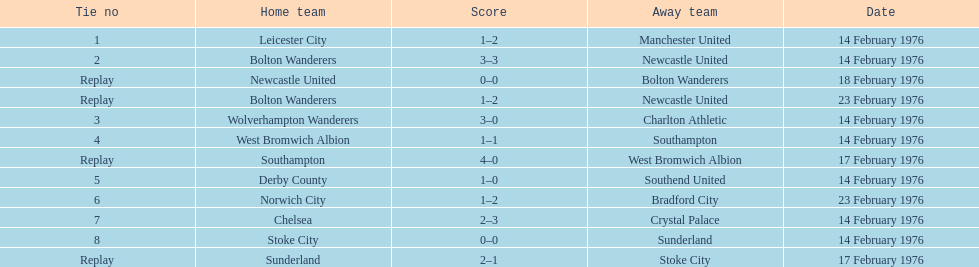How many games were reenactments? 4. 